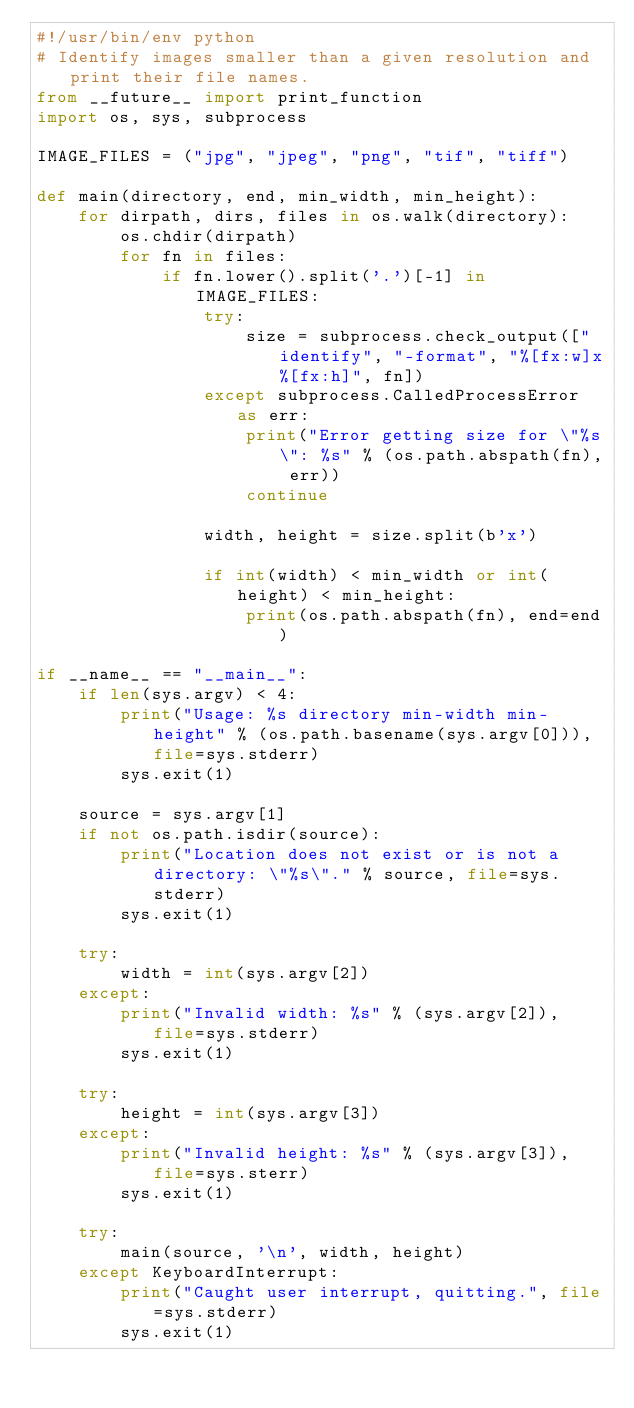Convert code to text. <code><loc_0><loc_0><loc_500><loc_500><_Python_>#!/usr/bin/env python
# Identify images smaller than a given resolution and print their file names.
from __future__ import print_function
import os, sys, subprocess

IMAGE_FILES = ("jpg", "jpeg", "png", "tif", "tiff")

def main(directory, end, min_width, min_height):
    for dirpath, dirs, files in os.walk(directory):
        os.chdir(dirpath)
        for fn in files:
            if fn.lower().split('.')[-1] in IMAGE_FILES:
                try:
                    size = subprocess.check_output(["identify", "-format", "%[fx:w]x%[fx:h]", fn])
                except subprocess.CalledProcessError as err:
                    print("Error getting size for \"%s\": %s" % (os.path.abspath(fn), err))
                    continue

                width, height = size.split(b'x')

                if int(width) < min_width or int(height) < min_height:
                    print(os.path.abspath(fn), end=end)

if __name__ == "__main__":
    if len(sys.argv) < 4:
        print("Usage: %s directory min-width min-height" % (os.path.basename(sys.argv[0])), file=sys.stderr)
        sys.exit(1)

    source = sys.argv[1]
    if not os.path.isdir(source):
        print("Location does not exist or is not a directory: \"%s\"." % source, file=sys.stderr)
        sys.exit(1)

    try:
        width = int(sys.argv[2])
    except:
        print("Invalid width: %s" % (sys.argv[2]), file=sys.stderr)
        sys.exit(1)

    try:
        height = int(sys.argv[3])
    except:
        print("Invalid height: %s" % (sys.argv[3]), file=sys.sterr)
        sys.exit(1)

    try:
        main(source, '\n', width, height)
    except KeyboardInterrupt:
        print("Caught user interrupt, quitting.", file=sys.stderr)
        sys.exit(1)

</code> 